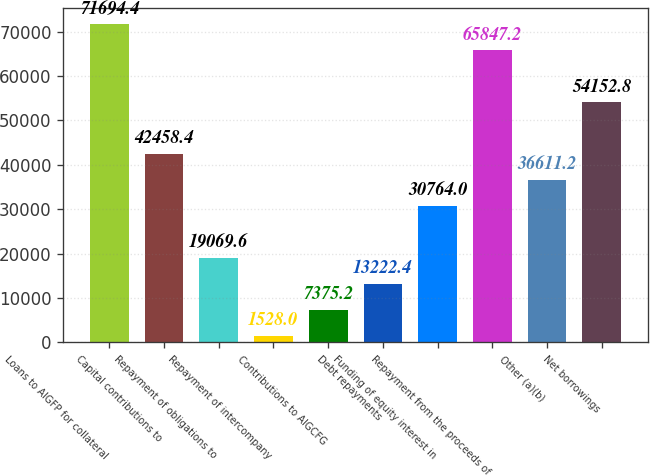<chart> <loc_0><loc_0><loc_500><loc_500><bar_chart><fcel>Loans to AIGFP for collateral<fcel>Capital contributions to<fcel>Repayment of obligations to<fcel>Repayment of intercompany<fcel>Contributions to AIGCFG<fcel>Debt repayments<fcel>Funding of equity interest in<fcel>Repayment from the proceeds of<fcel>Other (a)(b)<fcel>Net borrowings<nl><fcel>71694.4<fcel>42458.4<fcel>19069.6<fcel>1528<fcel>7375.2<fcel>13222.4<fcel>30764<fcel>65847.2<fcel>36611.2<fcel>54152.8<nl></chart> 